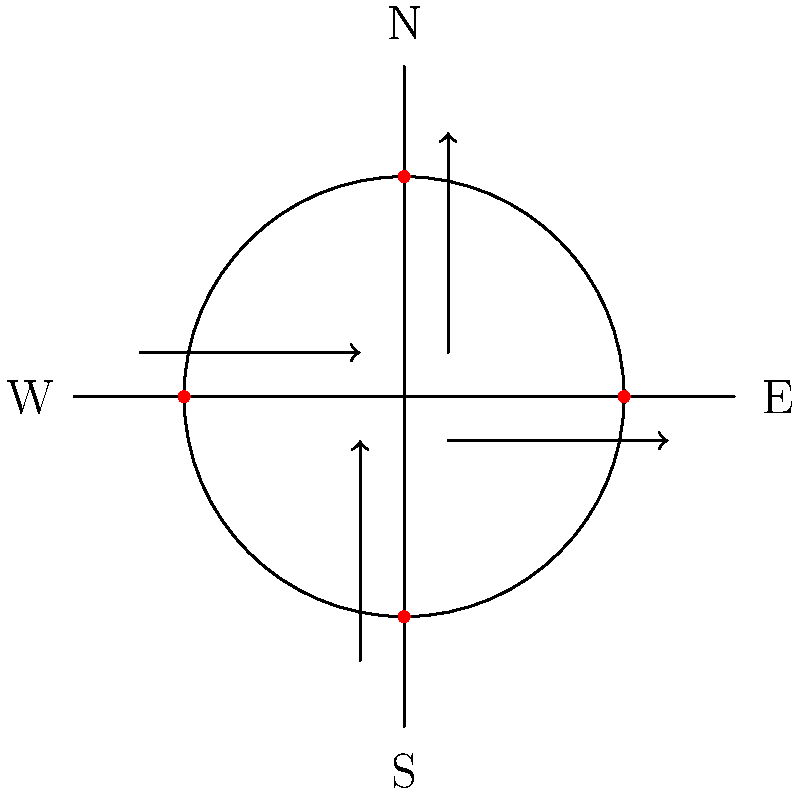A complex intersection with four-way traffic signals is experiencing congestion during peak hours. The current signal timing is fixed at 30 seconds for each direction. As a business administration professor with expertise in IT integration, how would you approach optimizing the traffic flow using smart traffic management systems? Consider the potential for real-time data collection and analysis in your solution. To optimize traffic flow at this complex intersection using smart traffic management systems, we can follow these steps:

1. Data Collection:
   - Install IoT sensors at each approach to the intersection to collect real-time data on traffic volume, vehicle types, and waiting times.
   - Implement computer vision systems to analyze traffic patterns and identify potential issues.

2. Data Integration:
   - Develop a centralized data platform to aggregate and process the collected data in real-time.
   - Integrate historical traffic data and external factors (e.g., weather conditions, events) into the system.

3. Predictive Analytics:
   - Apply machine learning algorithms to predict traffic patterns based on historical and real-time data.
   - Use these predictions to anticipate congestion and adjust signal timings proactively.

4. Dynamic Signal Control:
   - Implement an adaptive traffic signal control system that can adjust signal timings based on real-time traffic conditions.
   - Use the predictive analytics to optimize signal timings for each approach dynamically.

5. Vehicle-to-Infrastructure (V2I) Communication:
   - Implement V2I technology to allow direct communication between vehicles and traffic signals.
   - Use this data to further refine traffic flow predictions and signal timings.

6. Performance Monitoring and Optimization:
   - Continuously monitor key performance indicators (KPIs) such as average wait times, throughput, and emissions.
   - Use machine learning algorithms to continuously optimize the system based on these KPIs.

7. Multi-modal Integration:
   - Incorporate data from public transportation systems, pedestrian crossings, and bicycle lanes to ensure optimal flow for all road users.

8. User Interface and Reporting:
   - Develop a user-friendly dashboard for traffic managers to monitor and control the system.
   - Implement automated reporting systems to track long-term trends and system performance.

By implementing this IT-driven approach, we can create a smart, adaptive traffic management system that optimizes traffic flow based on real-time conditions and predictive analytics.
Answer: Implement a smart traffic management system with real-time data collection, predictive analytics, and dynamic signal control. 